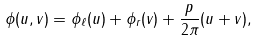Convert formula to latex. <formula><loc_0><loc_0><loc_500><loc_500>\phi ( u , v ) = \phi _ { \ell } ( u ) + \phi _ { r } ( v ) + \frac { p } { 2 \pi } ( u + v ) ,</formula> 